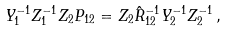<formula> <loc_0><loc_0><loc_500><loc_500>Y _ { 1 } ^ { - 1 } Z _ { 1 } ^ { - 1 } Z _ { 2 } P _ { 1 2 } = Z _ { 2 } \hat { R } _ { 1 2 } ^ { - 1 } Y _ { 2 } ^ { - 1 } Z _ { 2 } ^ { - 1 } \, ,</formula> 